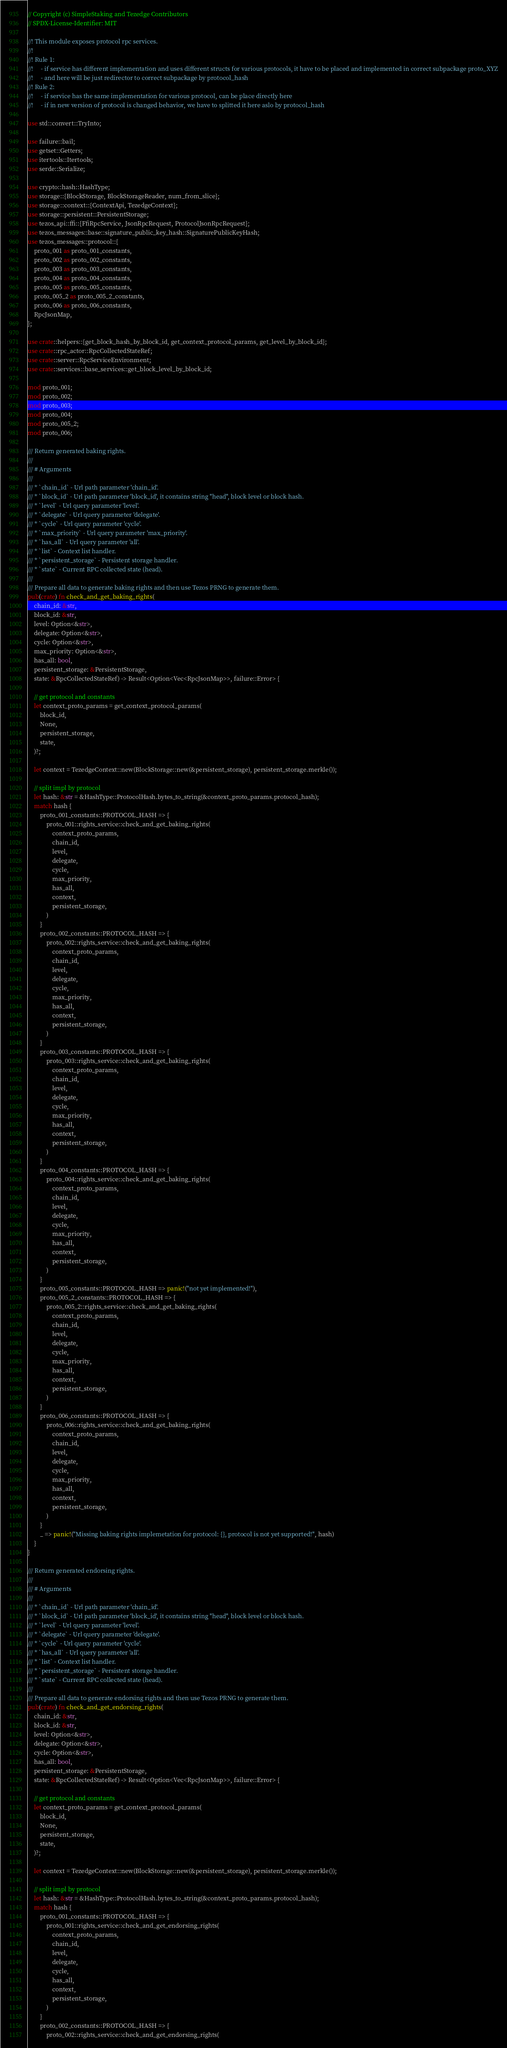Convert code to text. <code><loc_0><loc_0><loc_500><loc_500><_Rust_>// Copyright (c) SimpleStaking and Tezedge Contributors
// SPDX-License-Identifier: MIT

//! This module exposes protocol rpc services.
//!
//! Rule 1:
//!     - if service has different implementation and uses different structs for various protocols, it have to be placed and implemented in correct subpackage proto_XYZ
//!     - and here will be just redirector to correct subpackage by protocol_hash
//! Rule 2:
//!     - if service has the same implementation for various protocol, can be place directly here
//!     - if in new version of protocol is changed behavior, we have to splitted it here aslo by protocol_hash

use std::convert::TryInto;

use failure::bail;
use getset::Getters;
use itertools::Itertools;
use serde::Serialize;

use crypto::hash::HashType;
use storage::{BlockStorage, BlockStorageReader, num_from_slice};
use storage::context::{ContextApi, TezedgeContext};
use storage::persistent::PersistentStorage;
use tezos_api::ffi::{FfiRpcService, JsonRpcRequest, ProtocolJsonRpcRequest};
use tezos_messages::base::signature_public_key_hash::SignaturePublicKeyHash;
use tezos_messages::protocol::{
    proto_001 as proto_001_constants,
    proto_002 as proto_002_constants,
    proto_003 as proto_003_constants,
    proto_004 as proto_004_constants,
    proto_005 as proto_005_constants,
    proto_005_2 as proto_005_2_constants,
    proto_006 as proto_006_constants,
    RpcJsonMap,
};

use crate::helpers::{get_block_hash_by_block_id, get_context_protocol_params, get_level_by_block_id};
use crate::rpc_actor::RpcCollectedStateRef;
use crate::server::RpcServiceEnvironment;
use crate::services::base_services::get_block_level_by_block_id;

mod proto_001;
mod proto_002;
mod proto_003;
mod proto_004;
mod proto_005_2;
mod proto_006;

/// Return generated baking rights.
///
/// # Arguments
///
/// * `chain_id` - Url path parameter 'chain_id'.
/// * `block_id` - Url path parameter 'block_id', it contains string "head", block level or block hash.
/// * `level` - Url query parameter 'level'.
/// * `delegate` - Url query parameter 'delegate'.
/// * `cycle` - Url query parameter 'cycle'.
/// * `max_priority` - Url query parameter 'max_priority'.
/// * `has_all` - Url query parameter 'all'.
/// * `list` - Context list handler.
/// * `persistent_storage` - Persistent storage handler.
/// * `state` - Current RPC collected state (head).
///
/// Prepare all data to generate baking rights and then use Tezos PRNG to generate them.
pub(crate) fn check_and_get_baking_rights(
    chain_id: &str,
    block_id: &str,
    level: Option<&str>,
    delegate: Option<&str>,
    cycle: Option<&str>,
    max_priority: Option<&str>,
    has_all: bool,
    persistent_storage: &PersistentStorage,
    state: &RpcCollectedStateRef) -> Result<Option<Vec<RpcJsonMap>>, failure::Error> {

    // get protocol and constants
    let context_proto_params = get_context_protocol_params(
        block_id,
        None,
        persistent_storage,
        state,
    )?;

    let context = TezedgeContext::new(BlockStorage::new(&persistent_storage), persistent_storage.merkle());

    // split impl by protocol
    let hash: &str = &HashType::ProtocolHash.bytes_to_string(&context_proto_params.protocol_hash);
    match hash {
        proto_001_constants::PROTOCOL_HASH => {
            proto_001::rights_service::check_and_get_baking_rights(
                context_proto_params,
                chain_id,
                level,
                delegate,
                cycle,
                max_priority,
                has_all,
                context,
                persistent_storage,
            )
        }
        proto_002_constants::PROTOCOL_HASH => {
            proto_002::rights_service::check_and_get_baking_rights(
                context_proto_params,
                chain_id,
                level,
                delegate,
                cycle,
                max_priority,
                has_all,
                context,
                persistent_storage,
            )
        }
        proto_003_constants::PROTOCOL_HASH => {
            proto_003::rights_service::check_and_get_baking_rights(
                context_proto_params,
                chain_id,
                level,
                delegate,
                cycle,
                max_priority,
                has_all,
                context,
                persistent_storage,
            )
        }
        proto_004_constants::PROTOCOL_HASH => {
            proto_004::rights_service::check_and_get_baking_rights(
                context_proto_params,
                chain_id,
                level,
                delegate,
                cycle,
                max_priority,
                has_all,
                context,
                persistent_storage,
            )
        }
        proto_005_constants::PROTOCOL_HASH => panic!("not yet implemented!"),
        proto_005_2_constants::PROTOCOL_HASH => {
            proto_005_2::rights_service::check_and_get_baking_rights(
                context_proto_params,
                chain_id,
                level,
                delegate,
                cycle,
                max_priority,
                has_all,
                context,
                persistent_storage,
            )
        }
        proto_006_constants::PROTOCOL_HASH => {
            proto_006::rights_service::check_and_get_baking_rights(
                context_proto_params,
                chain_id,
                level,
                delegate,
                cycle,
                max_priority,
                has_all,
                context,
                persistent_storage,
            )
        }
        _ => panic!("Missing baking rights implemetation for protocol: {}, protocol is not yet supported!", hash)
    }
}

/// Return generated endorsing rights.
///
/// # Arguments
///
/// * `chain_id` - Url path parameter 'chain_id'.
/// * `block_id` - Url path parameter 'block_id', it contains string "head", block level or block hash.
/// * `level` - Url query parameter 'level'.
/// * `delegate` - Url query parameter 'delegate'.
/// * `cycle` - Url query parameter 'cycle'.
/// * `has_all` - Url query parameter 'all'.
/// * `list` - Context list handler.
/// * `persistent_storage` - Persistent storage handler.
/// * `state` - Current RPC collected state (head).
///
/// Prepare all data to generate endorsing rights and then use Tezos PRNG to generate them.
pub(crate) fn check_and_get_endorsing_rights(
    chain_id: &str,
    block_id: &str,
    level: Option<&str>,
    delegate: Option<&str>,
    cycle: Option<&str>,
    has_all: bool,
    persistent_storage: &PersistentStorage,
    state: &RpcCollectedStateRef) -> Result<Option<Vec<RpcJsonMap>>, failure::Error> {

    // get protocol and constants
    let context_proto_params = get_context_protocol_params(
        block_id,
        None,
        persistent_storage,
        state,
    )?;

    let context = TezedgeContext::new(BlockStorage::new(&persistent_storage), persistent_storage.merkle());

    // split impl by protocol
    let hash: &str = &HashType::ProtocolHash.bytes_to_string(&context_proto_params.protocol_hash);
    match hash {
        proto_001_constants::PROTOCOL_HASH => {
            proto_001::rights_service::check_and_get_endorsing_rights(
                context_proto_params,
                chain_id,
                level,
                delegate,
                cycle,
                has_all,
                context,
                persistent_storage,
            )
        }
        proto_002_constants::PROTOCOL_HASH => {
            proto_002::rights_service::check_and_get_endorsing_rights(</code> 